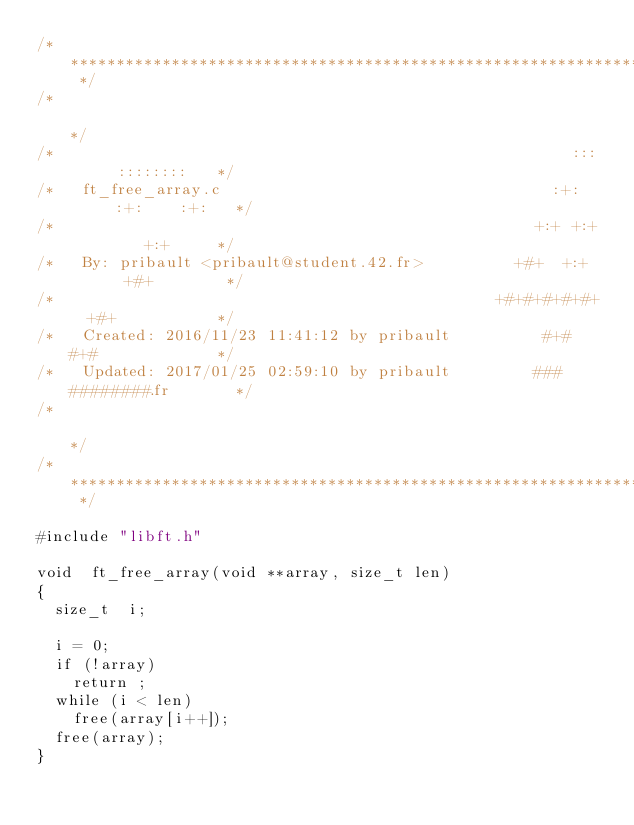Convert code to text. <code><loc_0><loc_0><loc_500><loc_500><_C_>/* ************************************************************************** */
/*                                                                            */
/*                                                        :::      ::::::::   */
/*   ft_free_array.c                                    :+:      :+:    :+:   */
/*                                                    +:+ +:+         +:+     */
/*   By: pribault <pribault@student.42.fr>          +#+  +:+       +#+        */
/*                                                +#+#+#+#+#+   +#+           */
/*   Created: 2016/11/23 11:41:12 by pribault          #+#    #+#             */
/*   Updated: 2017/01/25 02:59:10 by pribault         ###   ########.fr       */
/*                                                                            */
/* ************************************************************************** */

#include "libft.h"

void	ft_free_array(void **array, size_t len)
{
	size_t	i;

	i = 0;
	if (!array)
		return ;
	while (i < len)
		free(array[i++]);
	free(array);
}
</code> 